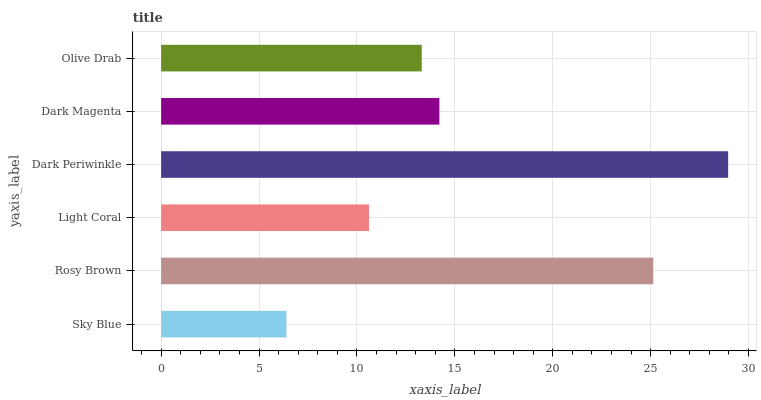Is Sky Blue the minimum?
Answer yes or no. Yes. Is Dark Periwinkle the maximum?
Answer yes or no. Yes. Is Rosy Brown the minimum?
Answer yes or no. No. Is Rosy Brown the maximum?
Answer yes or no. No. Is Rosy Brown greater than Sky Blue?
Answer yes or no. Yes. Is Sky Blue less than Rosy Brown?
Answer yes or no. Yes. Is Sky Blue greater than Rosy Brown?
Answer yes or no. No. Is Rosy Brown less than Sky Blue?
Answer yes or no. No. Is Dark Magenta the high median?
Answer yes or no. Yes. Is Olive Drab the low median?
Answer yes or no. Yes. Is Dark Periwinkle the high median?
Answer yes or no. No. Is Light Coral the low median?
Answer yes or no. No. 